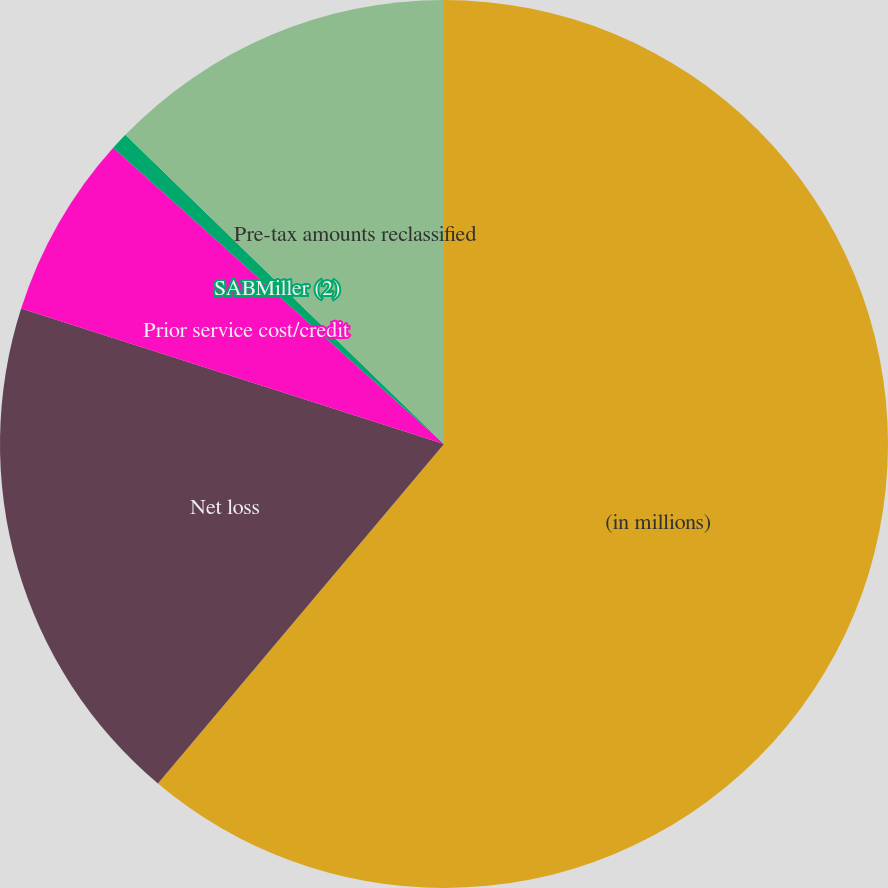Convert chart. <chart><loc_0><loc_0><loc_500><loc_500><pie_chart><fcel>(in millions)<fcel>Net loss<fcel>Prior service cost/credit<fcel>SABMiller (2)<fcel>Pre-tax amounts reclassified<nl><fcel>61.15%<fcel>18.79%<fcel>6.69%<fcel>0.64%<fcel>12.74%<nl></chart> 